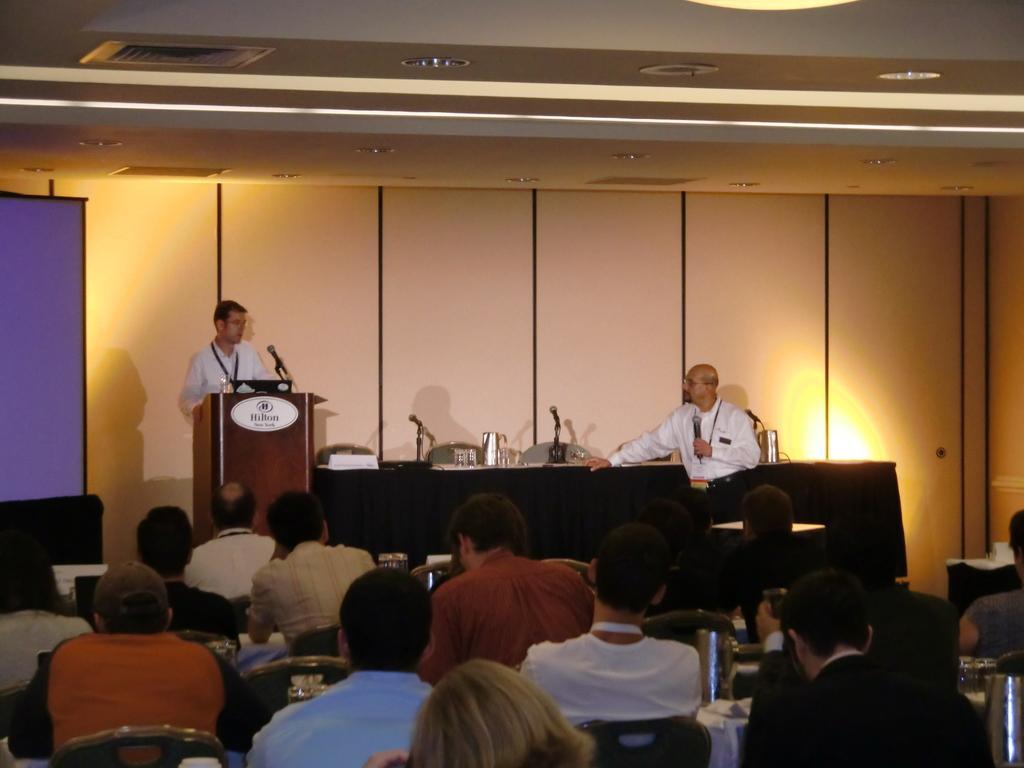Please provide a concise description of this image. In this image there are many people sitting on the chairs. In front of them there is a person standing at the podium. In front of him there is a podium. On the podium there is a microphone. Beside the microphone there is a laptop. Beside the podium there is a table. There is a cloth on the table. On the table there are microphones, glasses and name boards. There is another man standing to the right near to the table. Behind them there is a wall. To the left there is a projector board. At the top there are lights to the ceiling. 